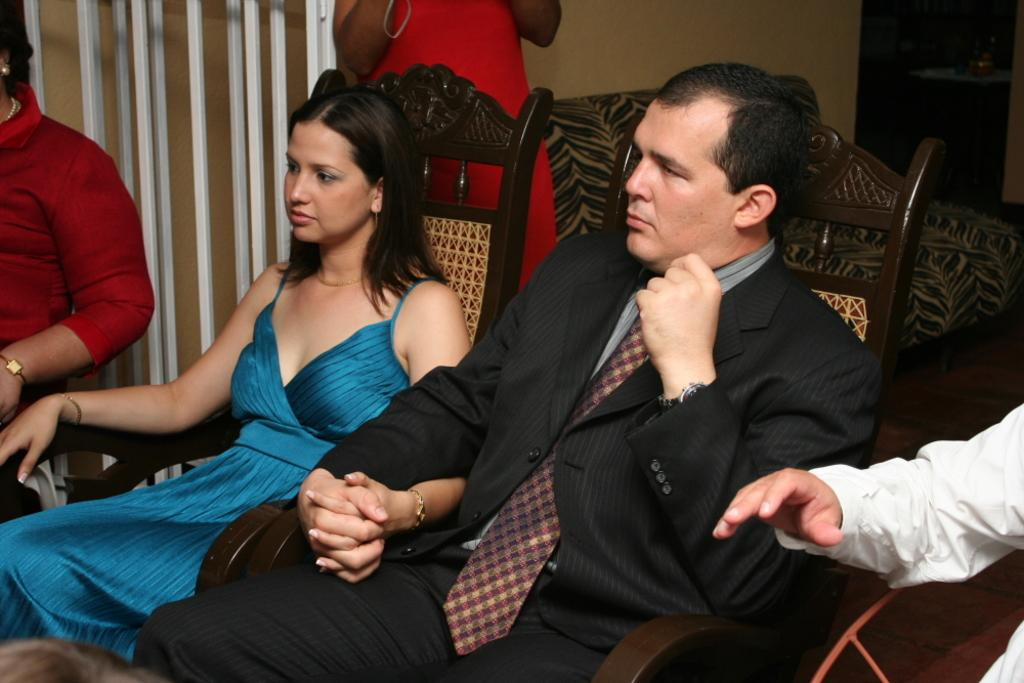What are the people in the image doing? The people in the image are sitting on chairs. Can you describe the background of the image? There is a lady, a wall, a couch, and metal rods in the background of the image. What type of mint can be seen growing on the couch in the image? There is no mint growing on the couch in the image; it is a piece of furniture in the background. 